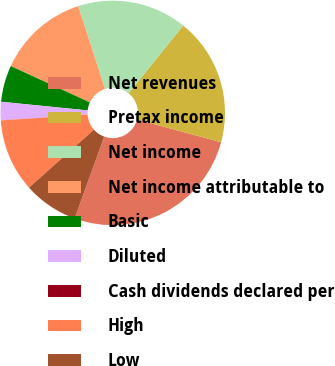<chart> <loc_0><loc_0><loc_500><loc_500><pie_chart><fcel>Net revenues<fcel>Pretax income<fcel>Net income<fcel>Net income attributable to<fcel>Basic<fcel>Diluted<fcel>Cash dividends declared per<fcel>High<fcel>Low<nl><fcel>26.31%<fcel>18.42%<fcel>15.79%<fcel>13.16%<fcel>5.27%<fcel>2.64%<fcel>0.01%<fcel>10.53%<fcel>7.9%<nl></chart> 